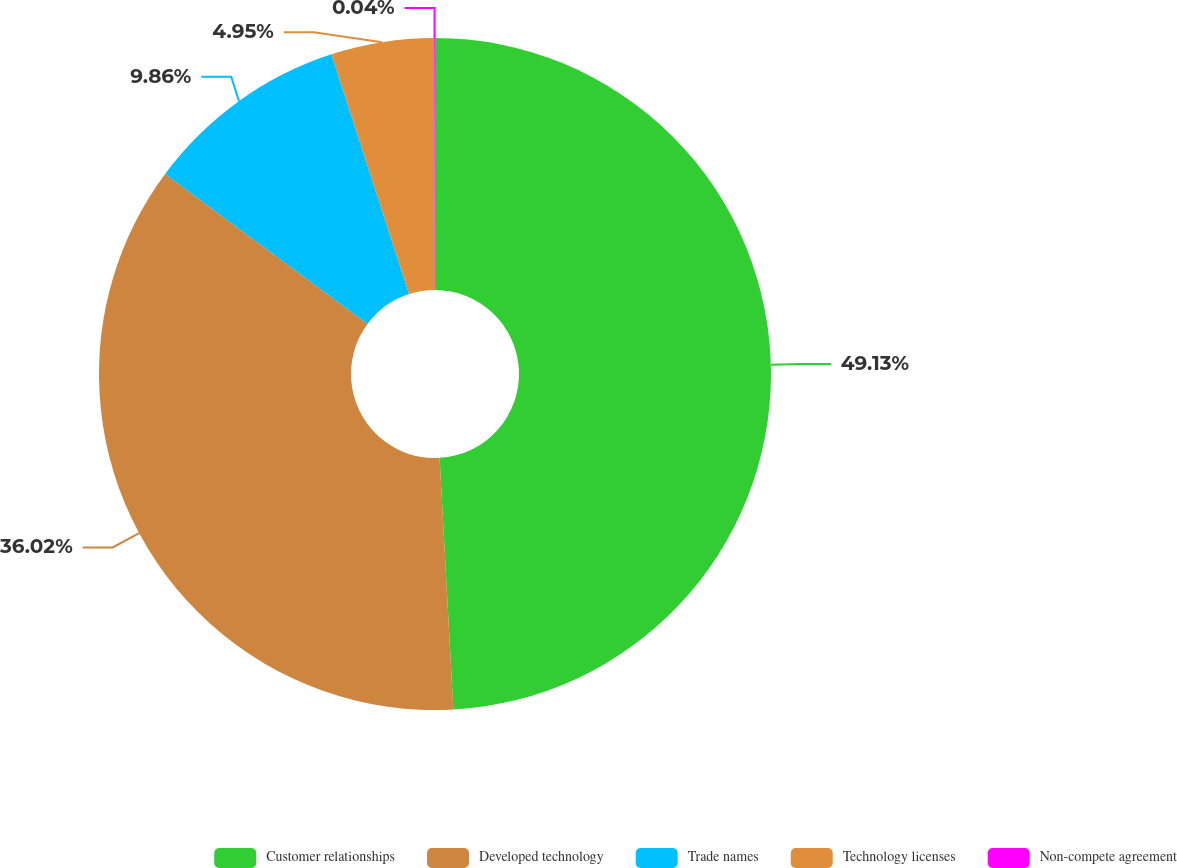Convert chart to OTSL. <chart><loc_0><loc_0><loc_500><loc_500><pie_chart><fcel>Customer relationships<fcel>Developed technology<fcel>Trade names<fcel>Technology licenses<fcel>Non-compete agreement<nl><fcel>49.14%<fcel>36.03%<fcel>9.86%<fcel>4.95%<fcel>0.04%<nl></chart> 